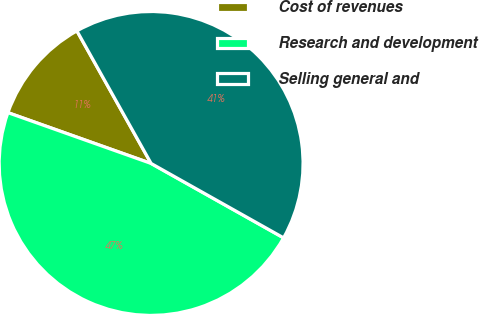Convert chart to OTSL. <chart><loc_0><loc_0><loc_500><loc_500><pie_chart><fcel>Cost of revenues<fcel>Research and development<fcel>Selling general and<nl><fcel>11.45%<fcel>47.29%<fcel>41.27%<nl></chart> 